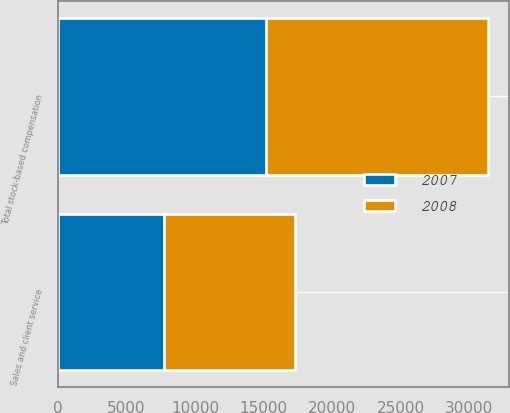Convert chart. <chart><loc_0><loc_0><loc_500><loc_500><stacked_bar_chart><ecel><fcel>Sales and client service<fcel>Total stock-based compensation<nl><fcel>2007<fcel>7750<fcel>15144<nl><fcel>2008<fcel>9518<fcel>16189<nl></chart> 